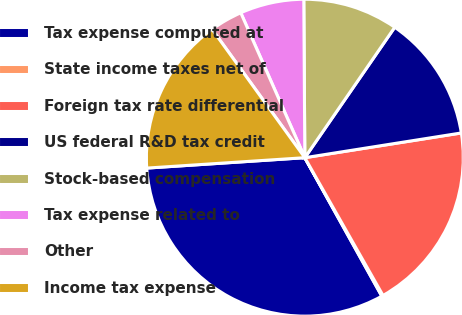Convert chart to OTSL. <chart><loc_0><loc_0><loc_500><loc_500><pie_chart><fcel>Tax expense computed at<fcel>State income taxes net of<fcel>Foreign tax rate differential<fcel>US federal R&D tax credit<fcel>Stock-based compensation<fcel>Tax expense related to<fcel>Other<fcel>Income tax expense<nl><fcel>32.03%<fcel>0.14%<fcel>19.28%<fcel>12.9%<fcel>9.71%<fcel>6.52%<fcel>3.33%<fcel>16.09%<nl></chart> 